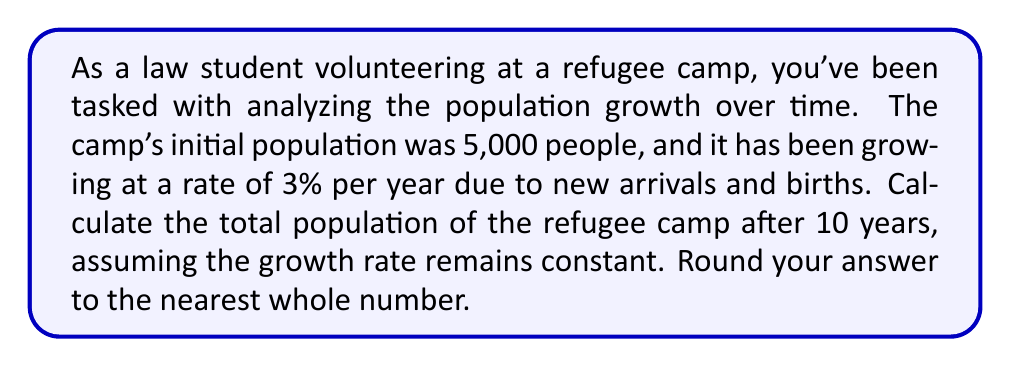Teach me how to tackle this problem. To solve this problem, we need to use the compound interest formula, which can be applied to population growth scenarios:

$$A = P(1 + r)^n$$

Where:
$A$ = Final amount (in this case, final population)
$P$ = Principal amount (initial population)
$r$ = Annual growth rate (as a decimal)
$n$ = Number of years

Given:
$P = 5,000$ (initial population)
$r = 0.03$ (3% expressed as a decimal)
$n = 10$ years

Let's substitute these values into the formula:

$$A = 5,000(1 + 0.03)^{10}$$

Now, let's solve step by step:

1) First, calculate $(1 + 0.03)^{10}$:
   $$(1.03)^{10} \approx 1.3439$$

2) Multiply this by the initial population:
   $$5,000 \times 1.3439 \approx 6,719.58$$

3) Round to the nearest whole number:
   $$6,720$$

Therefore, after 10 years, the refugee camp population will be approximately 6,720 people.
Answer: 6,720 people 